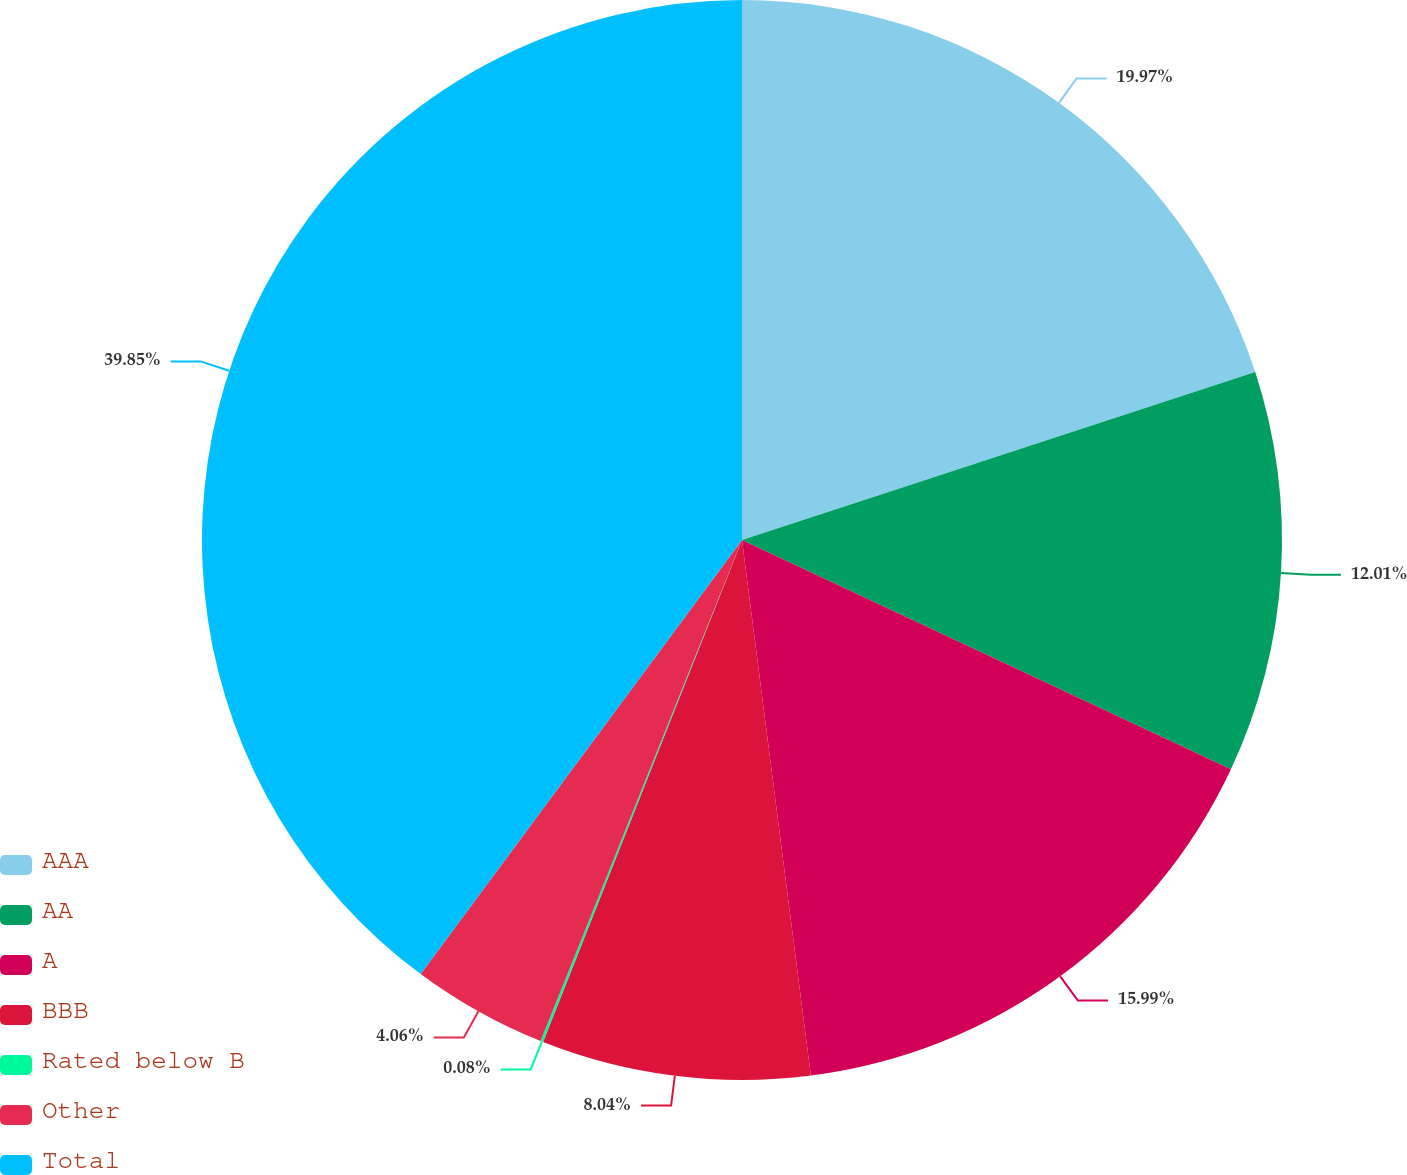<chart> <loc_0><loc_0><loc_500><loc_500><pie_chart><fcel>AAA<fcel>AA<fcel>A<fcel>BBB<fcel>Rated below B<fcel>Other<fcel>Total<nl><fcel>19.97%<fcel>12.01%<fcel>15.99%<fcel>8.04%<fcel>0.08%<fcel>4.06%<fcel>39.86%<nl></chart> 